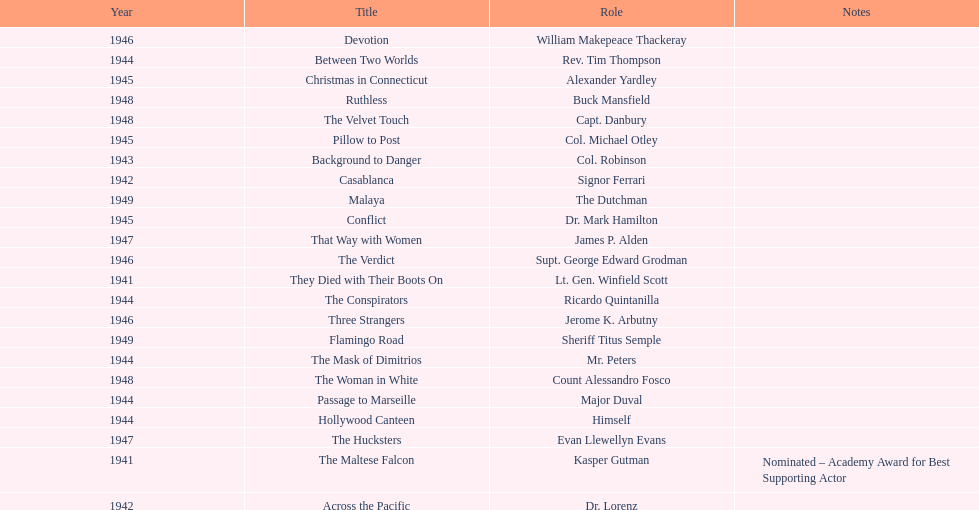Which movie did he get nominated for an oscar for? The Maltese Falcon. 